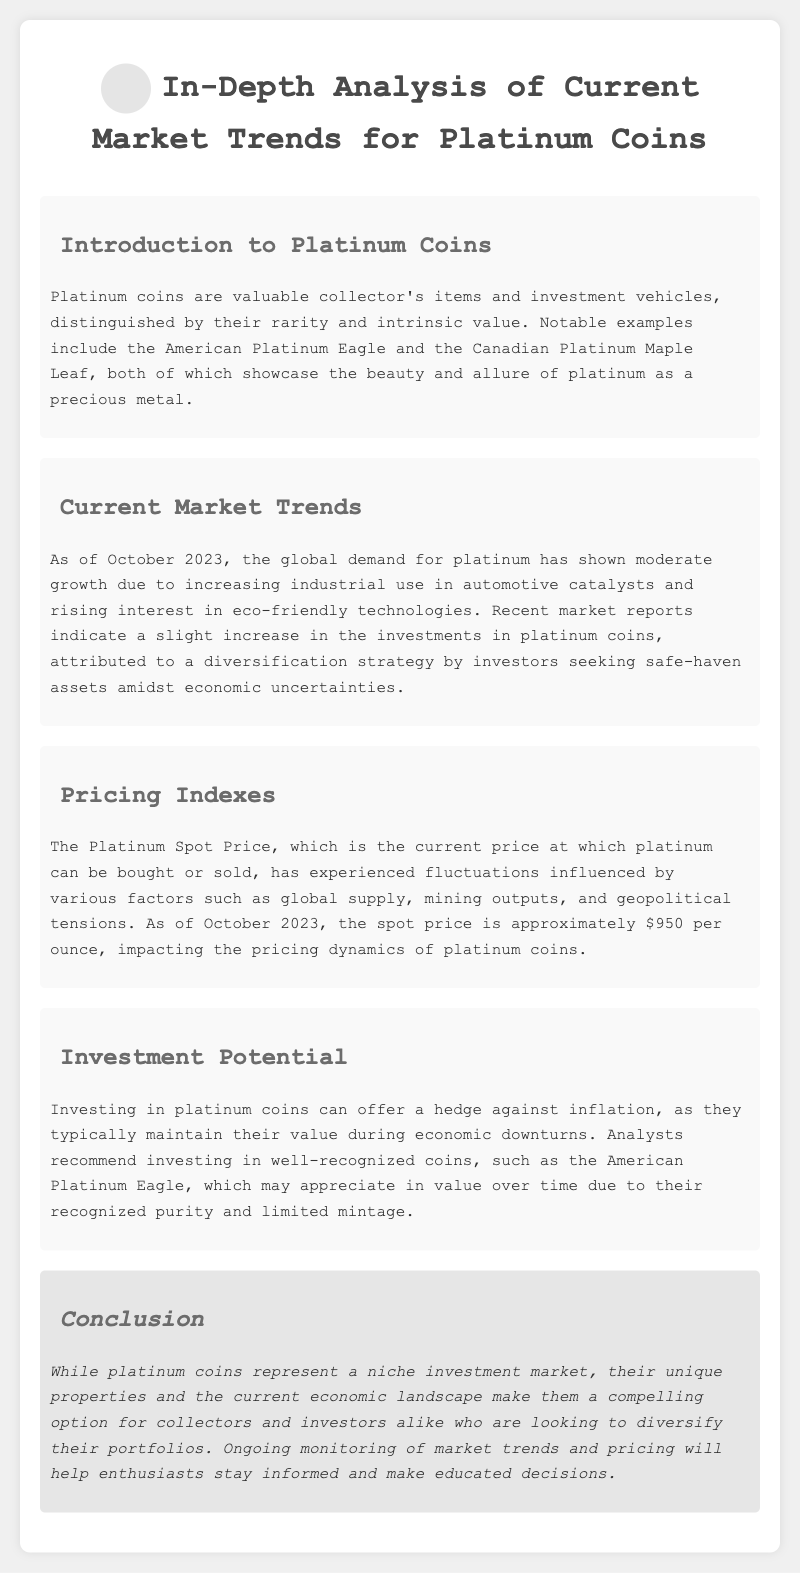What is the main focus of the document? The main focus of the document is an in-depth analysis of market trends for platinum coins, including pricing indexes and investment potential.
Answer: Platinum coins What is the spot price of platinum as of October 2023? The document states that the Platinum Spot Price is approximately $950 per ounce as of October 2023.
Answer: $950 per ounce Which two platinum coins are mentioned as notable examples? The document lists the American Platinum Eagle and the Canadian Platinum Maple Leaf as notable examples of platinum coins.
Answer: American Platinum Eagle and Canadian Platinum Maple Leaf What factor has contributed to the recent increase in investment in platinum coins? The document attributes the rise in investments in platinum coins to a diversification strategy by investors seeking safe-haven assets amidst economic uncertainties.
Answer: Diversification strategy What investment benefit is mentioned for platinum coins during economic downturns? According to the document, platinum coins can offer a hedge against inflation, maintaining their value during economic downturns.
Answer: Hedge against inflation Which analyst-recommended coin may appreciate in value over time? The document recommends investing in the American Platinum Eagle, as it may appreciate in value due to its recognized purity and limited mintage.
Answer: American Platinum Eagle What current economic trend is impacting the demand for platinum? The document indicates that the global demand for platinum has shown moderate growth due to increasing industrial use in automotive catalysts.
Answer: Increasing industrial use What type of document is this? This document is a manual providing an analysis of current market trends for platinum coins.
Answer: Manual 